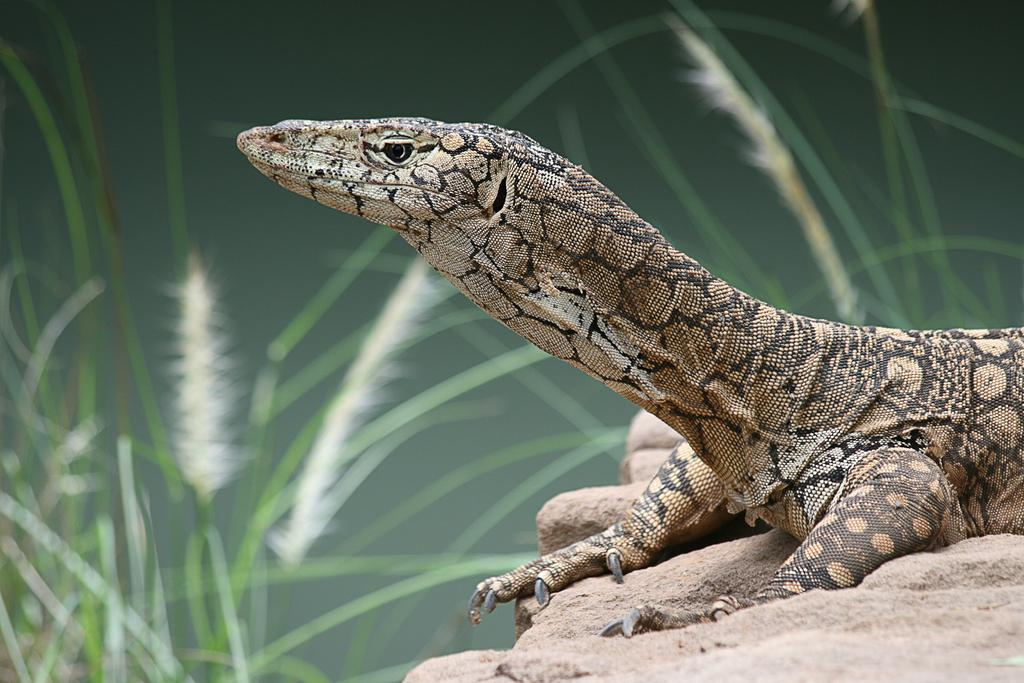What type of animal is in the image? A: There is a reptile in the image. Where is the reptile located? The reptile is on a rock. What can be seen in the background of the image? There are trees visible in the background of the image. How would you describe the background's appearance? The background appears blurred. What type of coal can be seen in the image? There is no coal present in the image. How low is the water level in the image? There is no water present in the image, so the water level cannot be determined. 